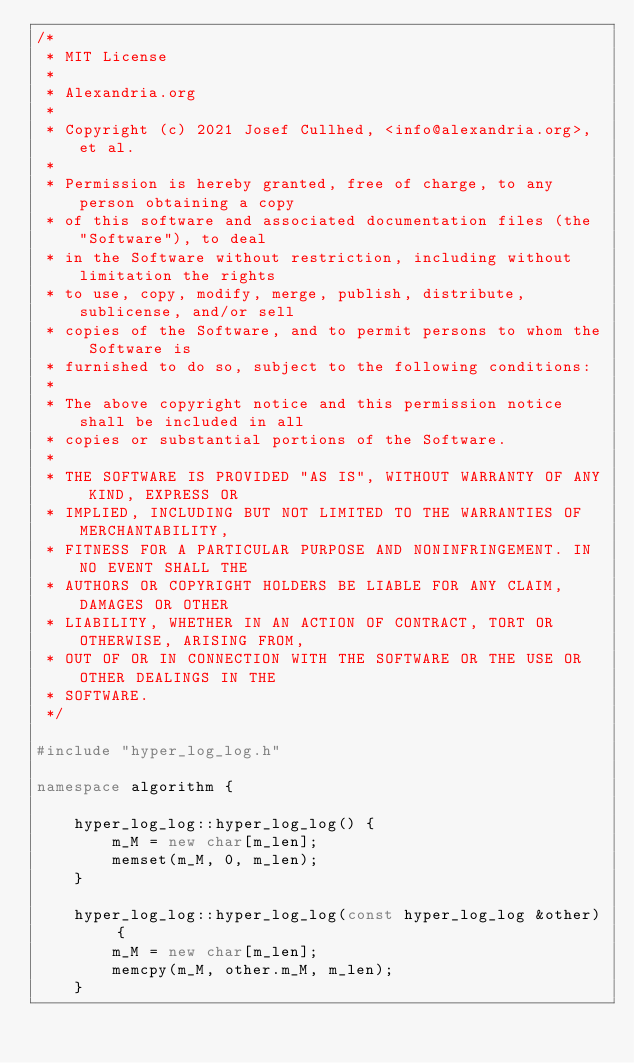Convert code to text. <code><loc_0><loc_0><loc_500><loc_500><_C++_>/*
 * MIT License
 *
 * Alexandria.org
 *
 * Copyright (c) 2021 Josef Cullhed, <info@alexandria.org>, et al.
 *
 * Permission is hereby granted, free of charge, to any person obtaining a copy
 * of this software and associated documentation files (the "Software"), to deal
 * in the Software without restriction, including without limitation the rights
 * to use, copy, modify, merge, publish, distribute, sublicense, and/or sell
 * copies of the Software, and to permit persons to whom the Software is
 * furnished to do so, subject to the following conditions:
 * 
 * The above copyright notice and this permission notice shall be included in all
 * copies or substantial portions of the Software.
 * 
 * THE SOFTWARE IS PROVIDED "AS IS", WITHOUT WARRANTY OF ANY KIND, EXPRESS OR
 * IMPLIED, INCLUDING BUT NOT LIMITED TO THE WARRANTIES OF MERCHANTABILITY,
 * FITNESS FOR A PARTICULAR PURPOSE AND NONINFRINGEMENT. IN NO EVENT SHALL THE
 * AUTHORS OR COPYRIGHT HOLDERS BE LIABLE FOR ANY CLAIM, DAMAGES OR OTHER
 * LIABILITY, WHETHER IN AN ACTION OF CONTRACT, TORT OR OTHERWISE, ARISING FROM,
 * OUT OF OR IN CONNECTION WITH THE SOFTWARE OR THE USE OR OTHER DEALINGS IN THE
 * SOFTWARE.
 */

#include "hyper_log_log.h"

namespace algorithm {

	hyper_log_log::hyper_log_log() {
		m_M = new char[m_len];
		memset(m_M, 0, m_len);
	}

	hyper_log_log::hyper_log_log(const hyper_log_log &other) {
		m_M = new char[m_len];
		memcpy(m_M, other.m_M, m_len);
	}
</code> 